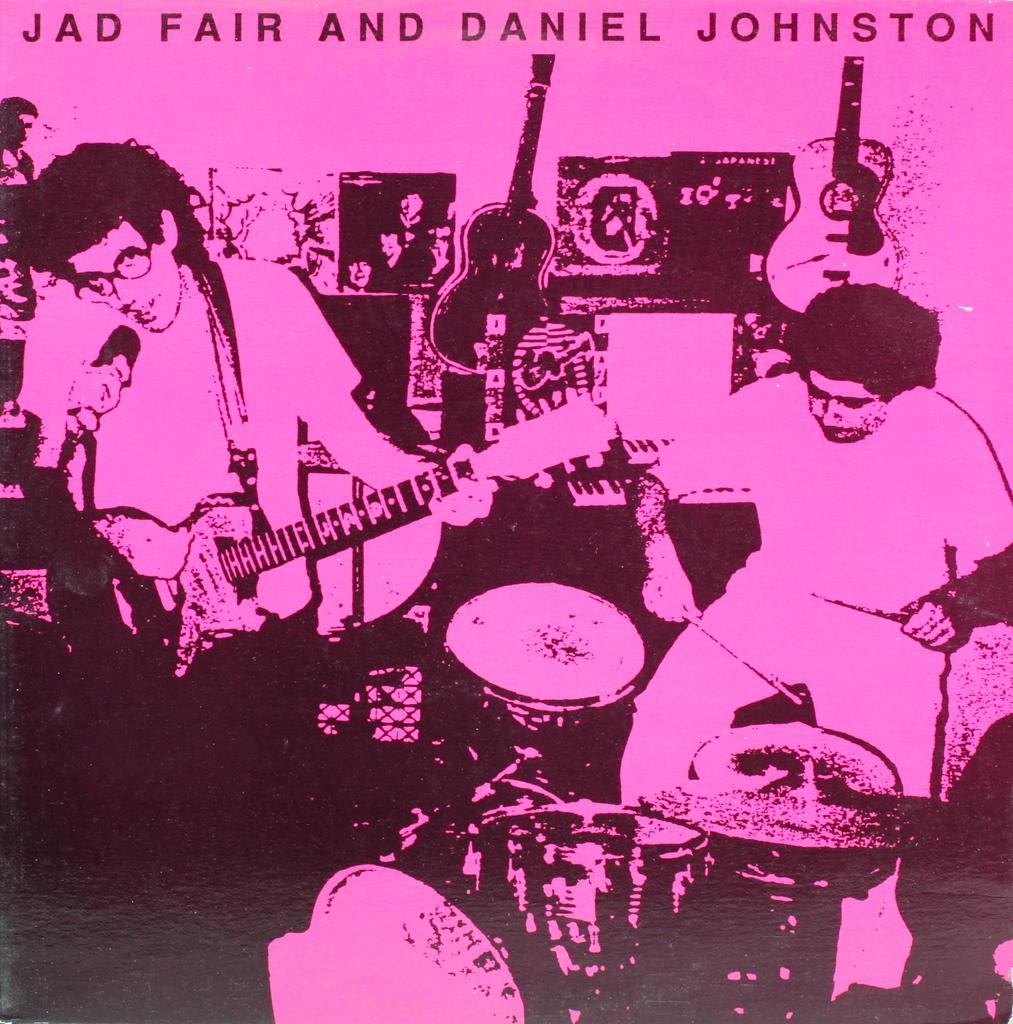Can you describe this image briefly? In this picture we can see musical instruments and people playing musical instruments. On the left side of the picture we can see people. At the top there is something written. 